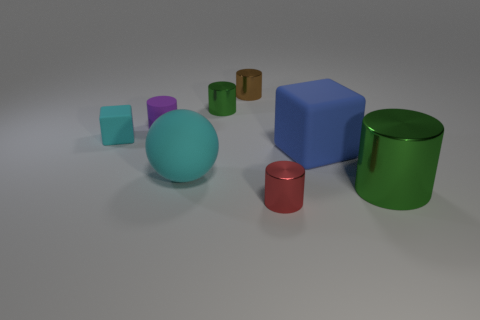There is a tiny block; is its color the same as the large thing to the left of the brown thing?
Your response must be concise. Yes. There is a small cylinder in front of the big green shiny object; are there any green metallic cylinders that are on the right side of it?
Your answer should be compact. Yes. The green metal thing that is on the right side of the tiny shiny cylinder that is in front of the small green thing is what shape?
Provide a short and direct response. Cylinder. Are there fewer large brown blocks than rubber cylinders?
Your response must be concise. Yes. Are the large blue cube and the tiny cube made of the same material?
Make the answer very short. Yes. What color is the metal cylinder that is both to the right of the small brown cylinder and behind the tiny red cylinder?
Your answer should be very brief. Green. Is there a purple rubber cylinder of the same size as the brown metallic cylinder?
Give a very brief answer. Yes. There is a object that is in front of the green cylinder right of the small brown object; what size is it?
Provide a succinct answer. Small. Is the number of tiny purple matte things on the right side of the big rubber cube less than the number of small purple metal objects?
Offer a terse response. No. Is the large matte sphere the same color as the tiny matte block?
Offer a very short reply. Yes. 